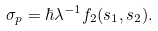<formula> <loc_0><loc_0><loc_500><loc_500>\sigma _ { p } = \hbar { \lambda } ^ { - 1 } f _ { 2 } ( s _ { 1 } , s _ { 2 } ) .</formula> 